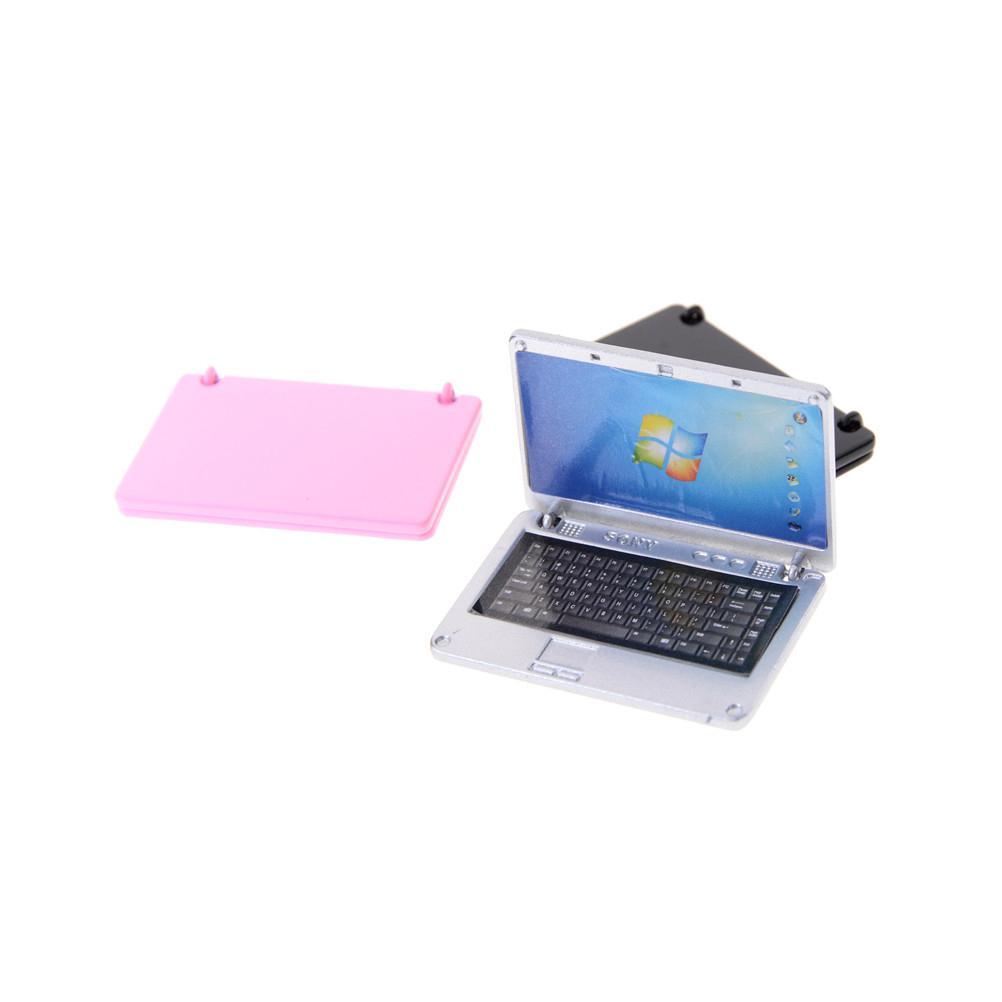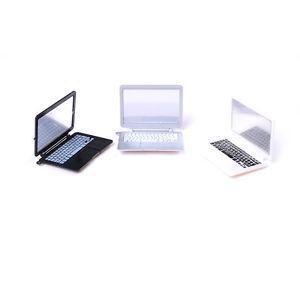The first image is the image on the left, the second image is the image on the right. For the images shown, is this caption "There are two miniature laptops." true? Answer yes or no. No. The first image is the image on the left, the second image is the image on the right. Analyze the images presented: Is the assertion "No single image contains more than two devices, and at least one image shows a hand holding a small white open device." valid? Answer yes or no. No. 